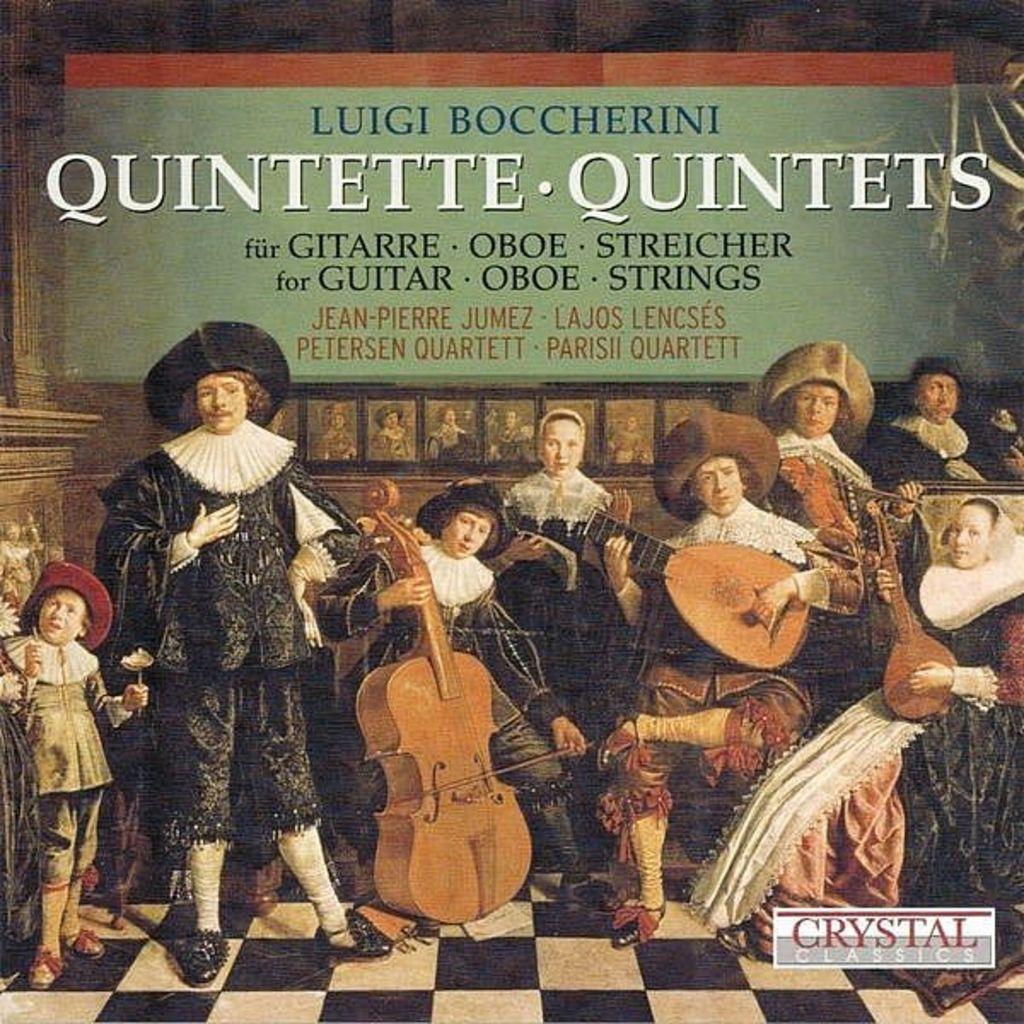Could you give a brief overview of what you see in this image? In this image I can see the group of people with black and white dresses and also the hats. I can see few people are holding the musical instruments. In the back there is a board and I can see something written on the board. 